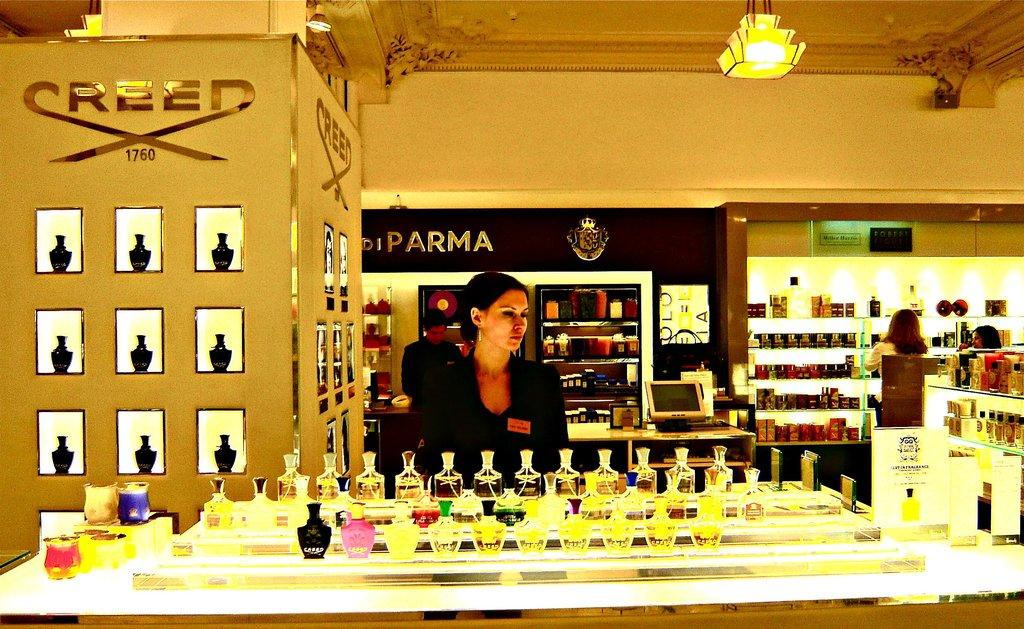<image>
Render a clear and concise summary of the photo. A woman in a black blazer is standing behind the creed perfume counter 